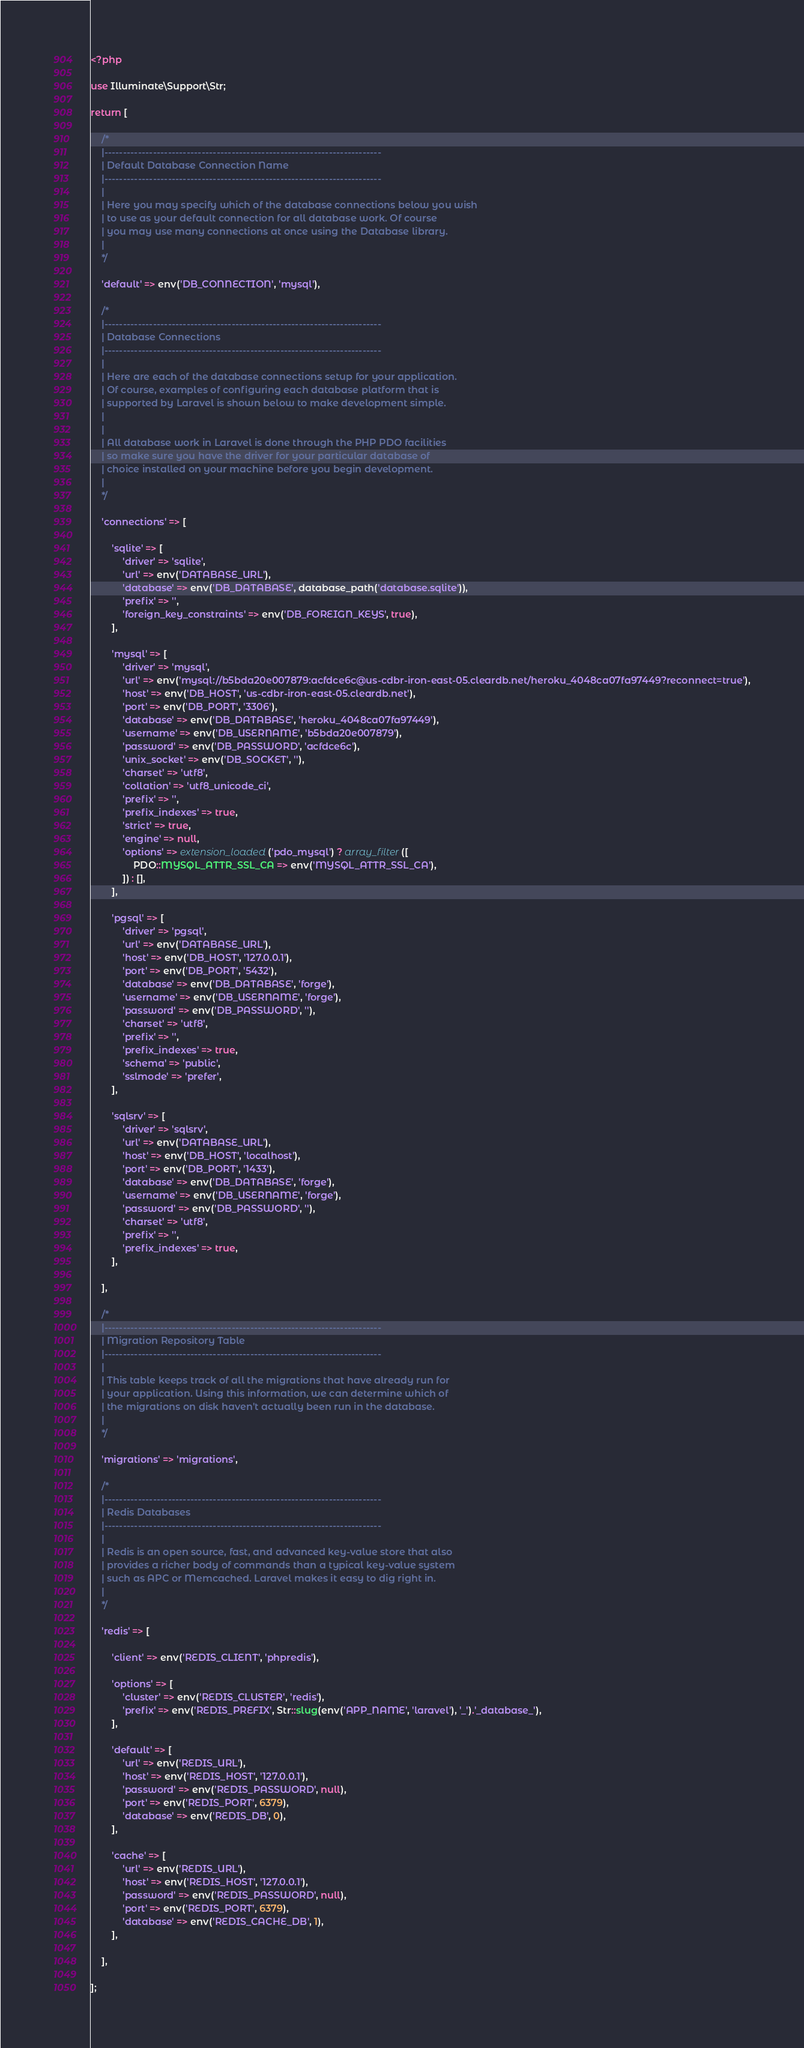<code> <loc_0><loc_0><loc_500><loc_500><_PHP_><?php

use Illuminate\Support\Str;

return [

    /*
    |--------------------------------------------------------------------------
    | Default Database Connection Name
    |--------------------------------------------------------------------------
    |
    | Here you may specify which of the database connections below you wish
    | to use as your default connection for all database work. Of course
    | you may use many connections at once using the Database library.
    |
    */

    'default' => env('DB_CONNECTION', 'mysql'),

    /*
    |--------------------------------------------------------------------------
    | Database Connections
    |--------------------------------------------------------------------------
    |
    | Here are each of the database connections setup for your application.
    | Of course, examples of configuring each database platform that is
    | supported by Laravel is shown below to make development simple.
    |
    |
    | All database work in Laravel is done through the PHP PDO facilities
    | so make sure you have the driver for your particular database of
    | choice installed on your machine before you begin development.
    |
    */

    'connections' => [

        'sqlite' => [
            'driver' => 'sqlite',
            'url' => env('DATABASE_URL'),
            'database' => env('DB_DATABASE', database_path('database.sqlite')),
            'prefix' => '',
            'foreign_key_constraints' => env('DB_FOREIGN_KEYS', true),
        ],

        'mysql' => [
            'driver' => 'mysql',
            'url' => env('mysql://b5bda20e007879:acfdce6c@us-cdbr-iron-east-05.cleardb.net/heroku_4048ca07fa97449?reconnect=true'),
            'host' => env('DB_HOST', 'us-cdbr-iron-east-05.cleardb.net'),
            'port' => env('DB_PORT', '3306'),
            'database' => env('DB_DATABASE', 'heroku_4048ca07fa97449'),
            'username' => env('DB_USERNAME', 'b5bda20e007879'),
            'password' => env('DB_PASSWORD', 'acfdce6c'),
            'unix_socket' => env('DB_SOCKET', ''),
            'charset' => 'utf8',
            'collation' => 'utf8_unicode_ci',
            'prefix' => '',
            'prefix_indexes' => true,
            'strict' => true,
            'engine' => null,
            'options' => extension_loaded('pdo_mysql') ? array_filter([
                PDO::MYSQL_ATTR_SSL_CA => env('MYSQL_ATTR_SSL_CA'),
            ]) : [],
        ],

        'pgsql' => [
            'driver' => 'pgsql',
            'url' => env('DATABASE_URL'),
            'host' => env('DB_HOST', '127.0.0.1'),
            'port' => env('DB_PORT', '5432'),
            'database' => env('DB_DATABASE', 'forge'),
            'username' => env('DB_USERNAME', 'forge'),
            'password' => env('DB_PASSWORD', ''),
            'charset' => 'utf8',
            'prefix' => '',
            'prefix_indexes' => true,
            'schema' => 'public',
            'sslmode' => 'prefer',
        ],

        'sqlsrv' => [
            'driver' => 'sqlsrv',
            'url' => env('DATABASE_URL'),
            'host' => env('DB_HOST', 'localhost'),
            'port' => env('DB_PORT', '1433'),
            'database' => env('DB_DATABASE', 'forge'),
            'username' => env('DB_USERNAME', 'forge'),
            'password' => env('DB_PASSWORD', ''),
            'charset' => 'utf8',
            'prefix' => '',
            'prefix_indexes' => true,
        ],

    ],

    /*
    |--------------------------------------------------------------------------
    | Migration Repository Table
    |--------------------------------------------------------------------------
    |
    | This table keeps track of all the migrations that have already run for
    | your application. Using this information, we can determine which of
    | the migrations on disk haven't actually been run in the database.
    |
    */

    'migrations' => 'migrations',

    /*
    |--------------------------------------------------------------------------
    | Redis Databases
    |--------------------------------------------------------------------------
    |
    | Redis is an open source, fast, and advanced key-value store that also
    | provides a richer body of commands than a typical key-value system
    | such as APC or Memcached. Laravel makes it easy to dig right in.
    |
    */

    'redis' => [

        'client' => env('REDIS_CLIENT', 'phpredis'),

        'options' => [
            'cluster' => env('REDIS_CLUSTER', 'redis'),
            'prefix' => env('REDIS_PREFIX', Str::slug(env('APP_NAME', 'laravel'), '_').'_database_'),
        ],

        'default' => [
            'url' => env('REDIS_URL'),
            'host' => env('REDIS_HOST', '127.0.0.1'),
            'password' => env('REDIS_PASSWORD', null),
            'port' => env('REDIS_PORT', 6379),
            'database' => env('REDIS_DB', 0),
        ],

        'cache' => [
            'url' => env('REDIS_URL'),
            'host' => env('REDIS_HOST', '127.0.0.1'),
            'password' => env('REDIS_PASSWORD', null),
            'port' => env('REDIS_PORT', 6379),
            'database' => env('REDIS_CACHE_DB', 1),
        ],

    ],

];
</code> 